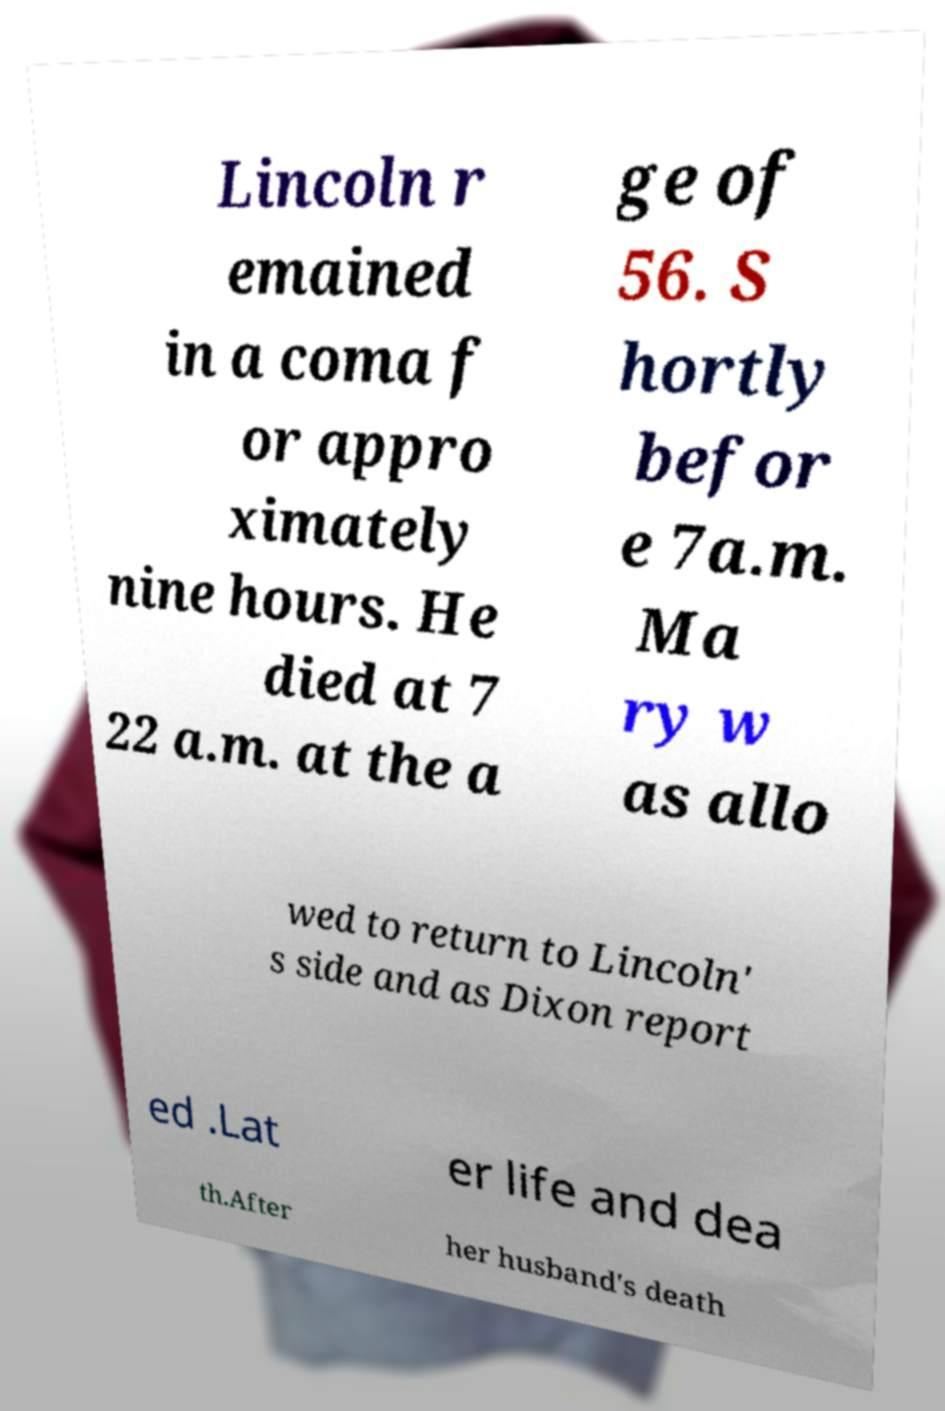Can you read and provide the text displayed in the image?This photo seems to have some interesting text. Can you extract and type it out for me? Lincoln r emained in a coma f or appro ximately nine hours. He died at 7 22 a.m. at the a ge of 56. S hortly befor e 7a.m. Ma ry w as allo wed to return to Lincoln' s side and as Dixon report ed .Lat er life and dea th.After her husband's death 